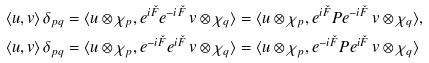Convert formula to latex. <formula><loc_0><loc_0><loc_500><loc_500>& \langle u , v \rangle \, \delta _ { p q } = \langle u \otimes \chi _ { p } , e ^ { i \check { F } } e ^ { - i \check { F } } \, v \otimes \chi _ { q } \rangle = \langle u \otimes \chi _ { p } , e ^ { i \check { F } } P e ^ { - i \check { F } } \, v \otimes \chi _ { q } \rangle , \\ & \langle u , v \rangle \, \delta _ { p q } = \langle u \otimes \chi _ { p } , e ^ { - i \check { F } } e ^ { i \check { F } } \, v \otimes \chi _ { q } \rangle = \langle u \otimes \chi _ { p } , e ^ { - i \check { F } } P e ^ { i \check { F } } \, v \otimes \chi _ { q } \rangle</formula> 